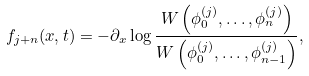<formula> <loc_0><loc_0><loc_500><loc_500>f _ { j + n } ( x , t ) = - \partial _ { x } \log \frac { W \left ( \phi _ { 0 } ^ { ( j ) } , \dots , \phi _ { n } ^ { ( j ) } \right ) } { W \left ( \phi _ { 0 } ^ { ( j ) } , \dots , \phi _ { n - 1 } ^ { ( j ) } \right ) } ,</formula> 